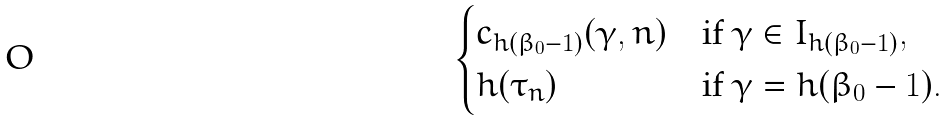<formula> <loc_0><loc_0><loc_500><loc_500>\begin{cases} c _ { h ( \beta _ { 0 } - 1 ) } ( \gamma , n ) & \text {if $\gamma \in I_{h(\beta_{0} - 1)}$} , \\ h ( \tau _ { n } ) & \text {if $\gamma = h(\beta_{0} - 1)$} . \end{cases}</formula> 